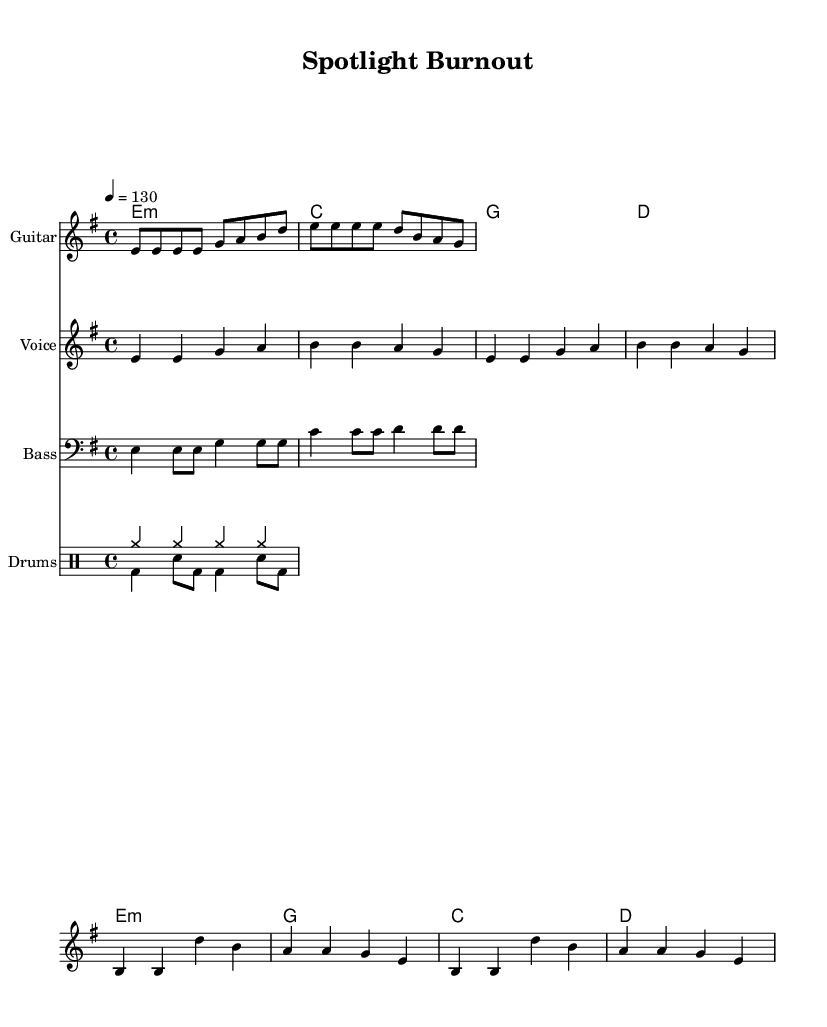What is the key signature of this music? The key signature is E minor, which contains one sharp (F#). This can be identified by looking at the beginning of the staff where the key signature is indicated.
Answer: E minor What is the time signature of the piece? The time signature is 4/4, which can be found at the start of the score. It shows that there are four beats in each measure.
Answer: 4/4 What is the tempo marking for this piece? The tempo marking indicates a metronome setting of 130 beats per minute, noted at the beginning of the score.
Answer: 130 What type of song structure is used in the lyrics? The lyrics have a verse and chorus structure, as indicated by the distinct lyrics for the verse and the chorus.
Answer: Verse and Chorus How many measures are in the chorus? The chorus consists of four measures, which can be counted from the music notation in the chorus section where the melody and lyrics are provided.
Answer: 4 What instrument plays the guitar riff? The guitar riff is indicated to be played on the guitar, as shown by the label above the staff.
Answer: Guitar What theme is present in the lyrics? The theme present in the lyrics reflects the pressures of the entertainment industry, as indicated by phrases like "spotlight burn-out" and "hide away the pain."
Answer: Pressures of the entertainment industry 